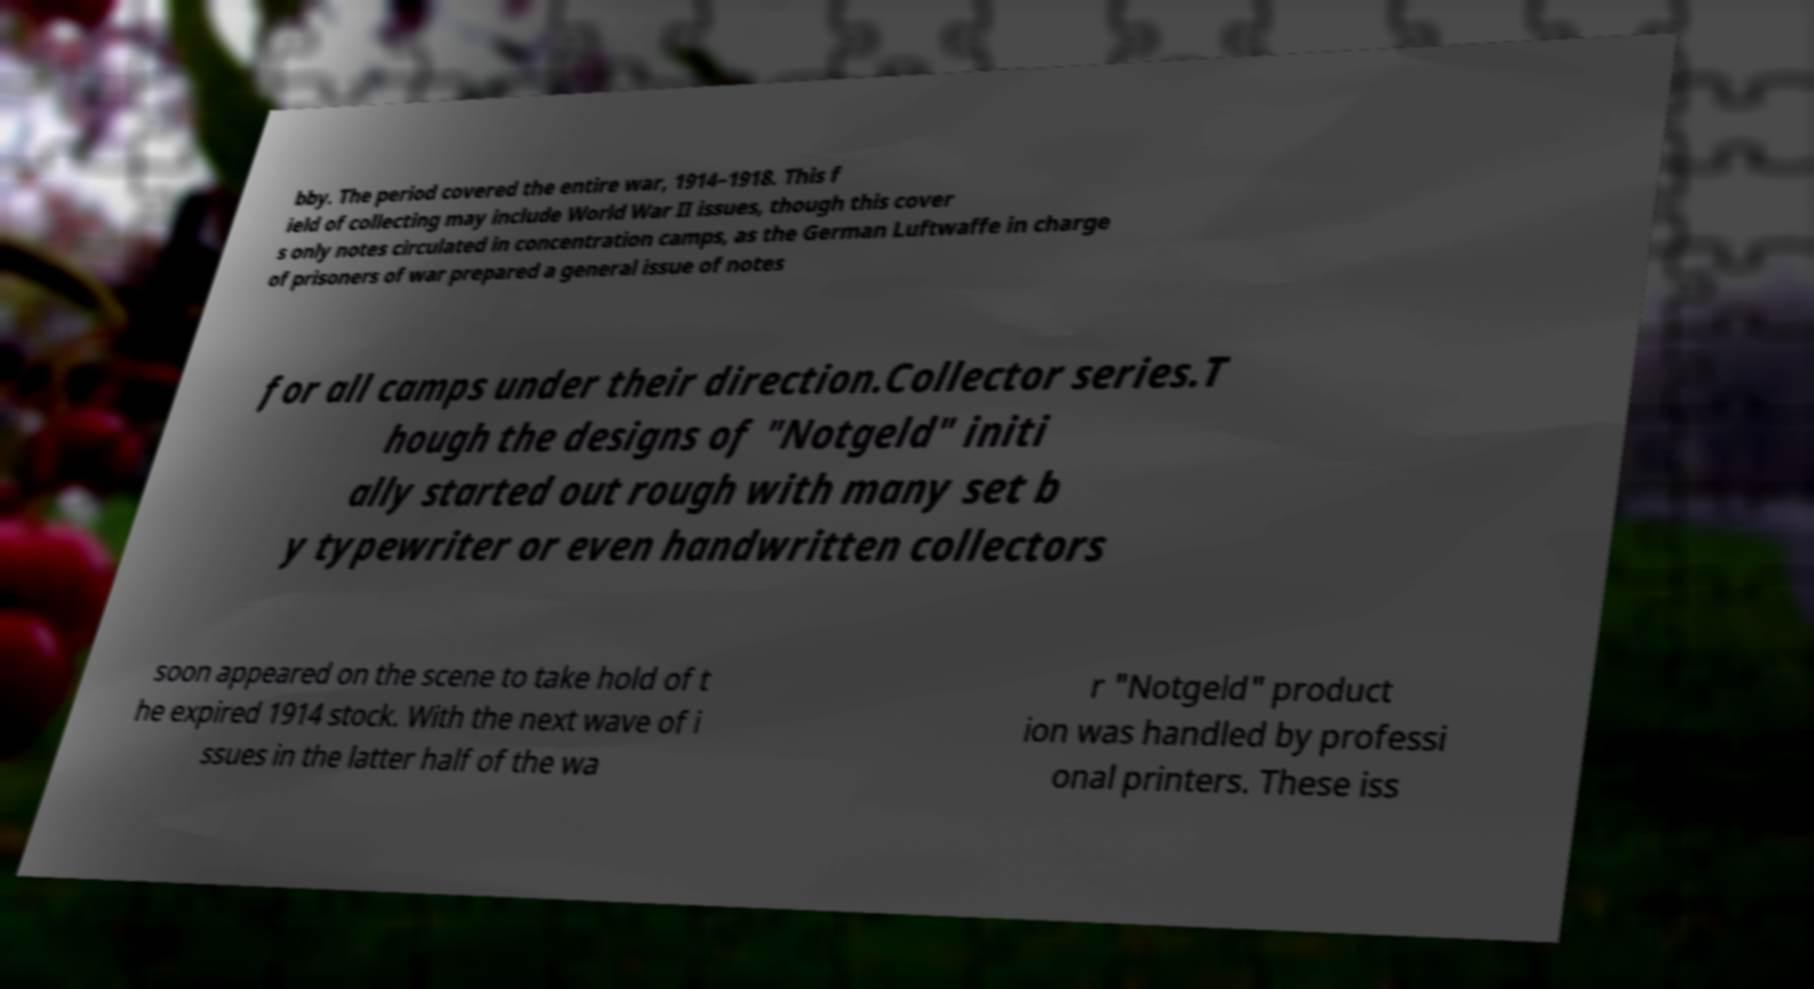Could you extract and type out the text from this image? bby. The period covered the entire war, 1914–1918. This f ield of collecting may include World War II issues, though this cover s only notes circulated in concentration camps, as the German Luftwaffe in charge of prisoners of war prepared a general issue of notes for all camps under their direction.Collector series.T hough the designs of "Notgeld" initi ally started out rough with many set b y typewriter or even handwritten collectors soon appeared on the scene to take hold of t he expired 1914 stock. With the next wave of i ssues in the latter half of the wa r "Notgeld" product ion was handled by professi onal printers. These iss 